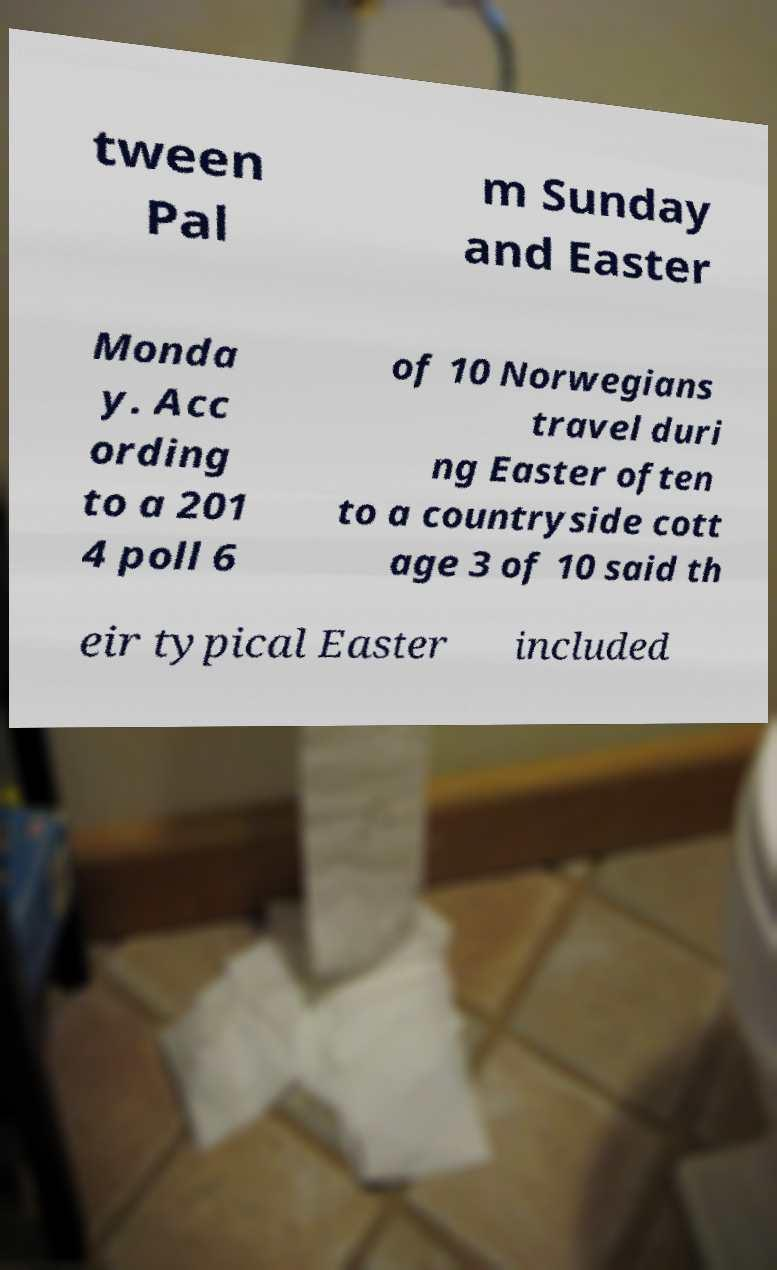I need the written content from this picture converted into text. Can you do that? tween Pal m Sunday and Easter Monda y. Acc ording to a 201 4 poll 6 of 10 Norwegians travel duri ng Easter often to a countryside cott age 3 of 10 said th eir typical Easter included 